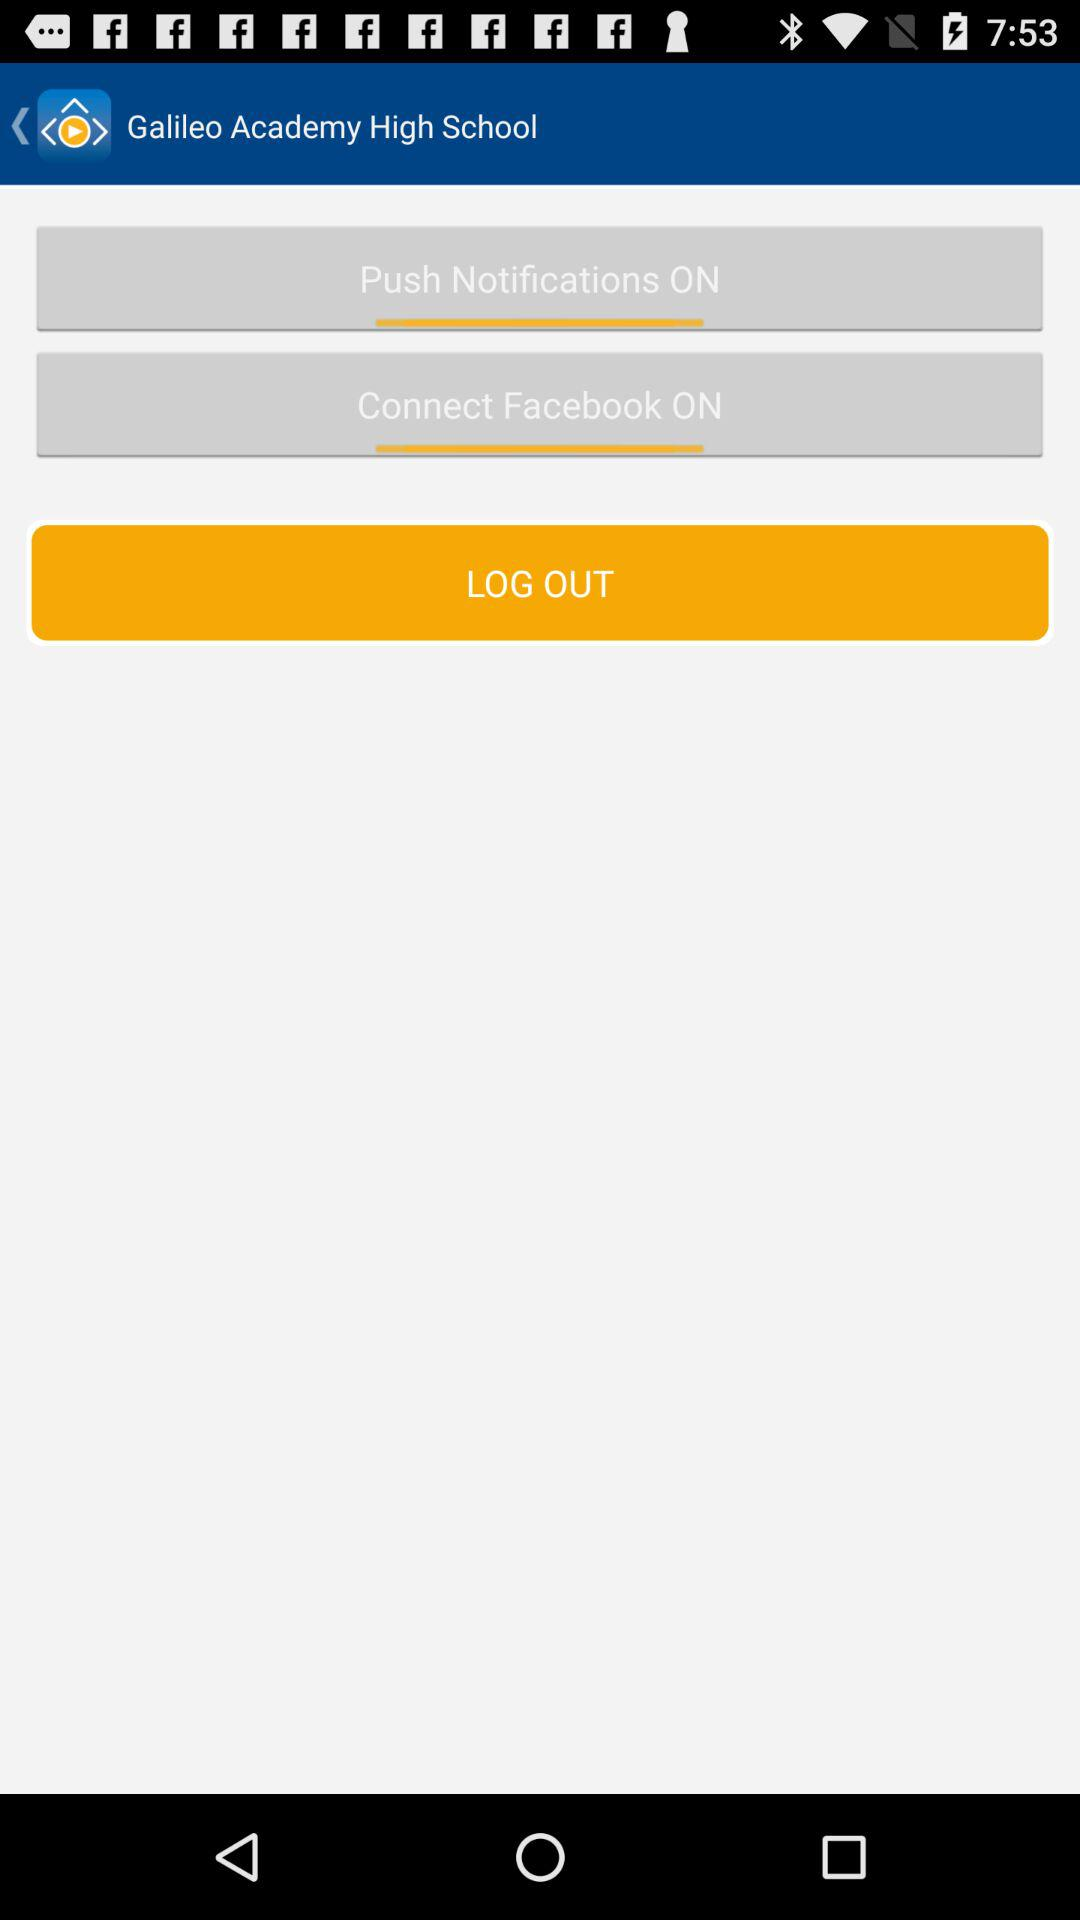Who is this application powered by?
When the provided information is insufficient, respond with <no answer>. <no answer> 